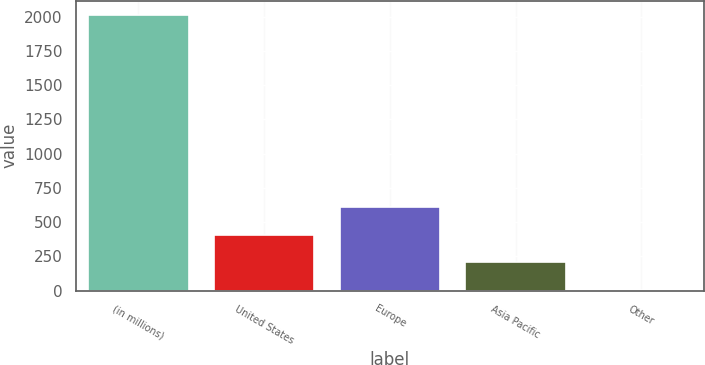Convert chart to OTSL. <chart><loc_0><loc_0><loc_500><loc_500><bar_chart><fcel>(in millions)<fcel>United States<fcel>Europe<fcel>Asia Pacific<fcel>Other<nl><fcel>2017<fcel>409<fcel>610<fcel>208<fcel>7<nl></chart> 